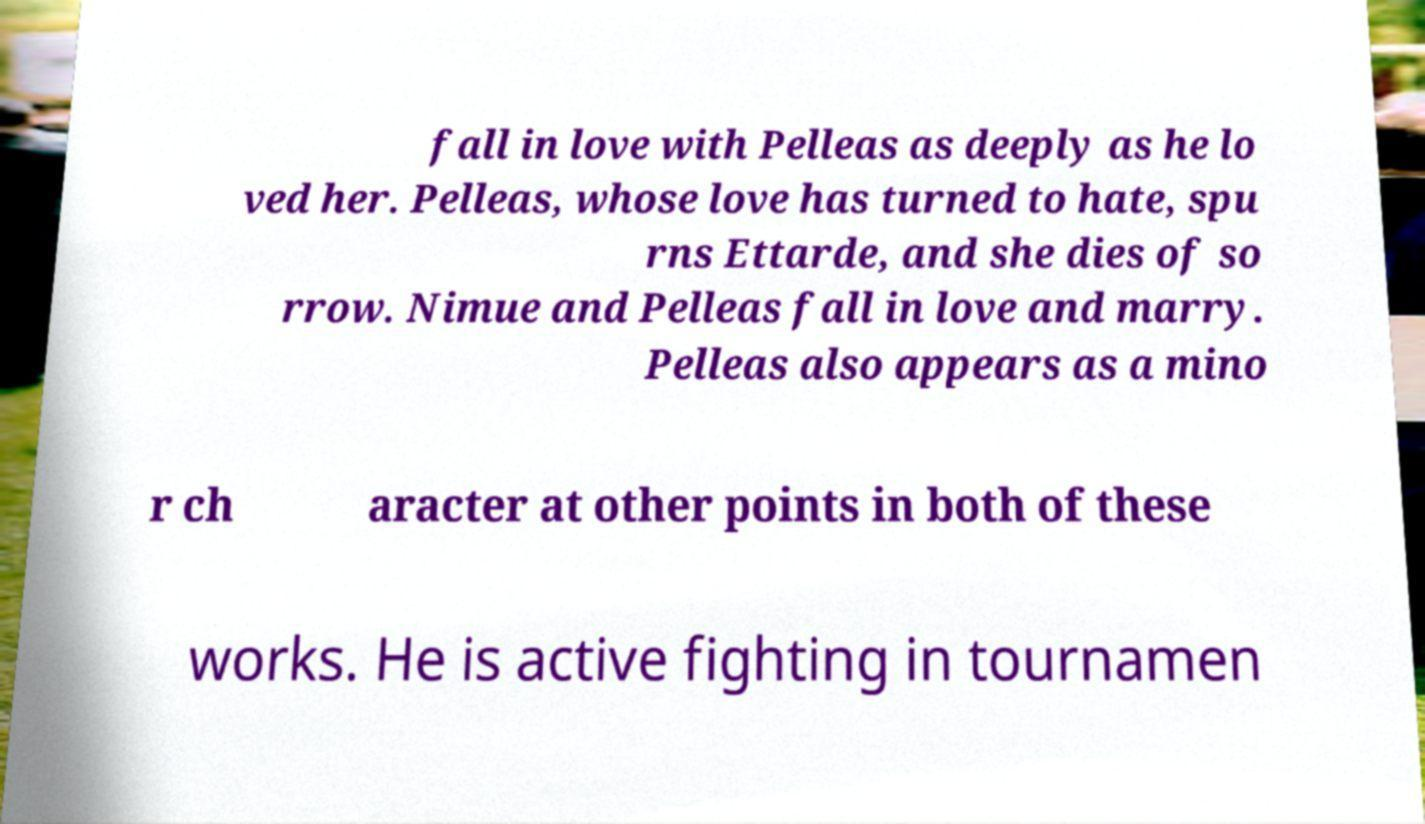I need the written content from this picture converted into text. Can you do that? fall in love with Pelleas as deeply as he lo ved her. Pelleas, whose love has turned to hate, spu rns Ettarde, and she dies of so rrow. Nimue and Pelleas fall in love and marry. Pelleas also appears as a mino r ch aracter at other points in both of these works. He is active fighting in tournamen 